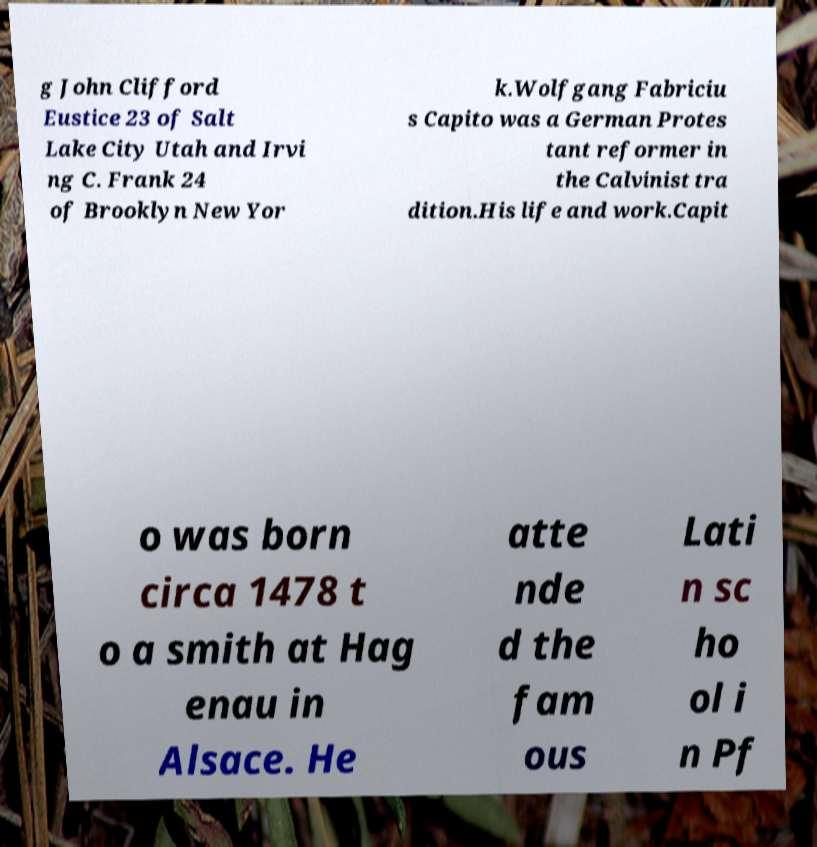There's text embedded in this image that I need extracted. Can you transcribe it verbatim? g John Clifford Eustice 23 of Salt Lake City Utah and Irvi ng C. Frank 24 of Brooklyn New Yor k.Wolfgang Fabriciu s Capito was a German Protes tant reformer in the Calvinist tra dition.His life and work.Capit o was born circa 1478 t o a smith at Hag enau in Alsace. He atte nde d the fam ous Lati n sc ho ol i n Pf 